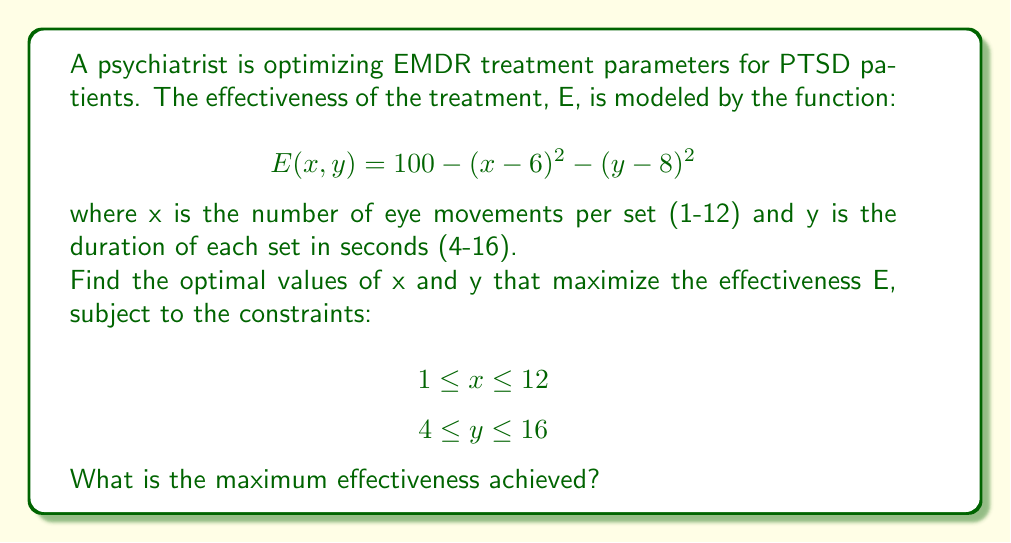Give your solution to this math problem. To solve this nonlinear programming problem, we'll follow these steps:

1) First, we need to find the critical points of the function E(x, y). We do this by taking partial derivatives and setting them to zero:

   $\frac{\partial E}{\partial x} = -2(x - 6) = 0$
   $\frac{\partial E}{\partial y} = -2(y - 8) = 0$

2) Solving these equations:
   $x = 6$
   $y = 8$

3) This critical point (6, 8) is within our constraints, so it's a candidate for the maximum.

4) To confirm it's a maximum, we can check the second derivatives:

   $\frac{\partial^2 E}{\partial x^2} = -2$
   $\frac{\partial^2 E}{\partial y^2} = -2$

   Both are negative, confirming this is a local maximum.

5) We should also check the boundaries of our constraints:

   At x = 1: E(1, 8) = 75
   At x = 12: E(12, 8) = 64
   At y = 4: E(6, 4) = 84
   At y = 16: E(6, 16) = 36

6) The maximum value at the critical point (6, 8) is:

   E(6, 8) = 100 - (6 - 6)^2 - (8 - 8)^2 = 100

7) This is greater than all boundary values, so it's the global maximum within our constraints.

Therefore, the optimal parameters are x = 6 eye movements per set and y = 8 seconds per set, achieving a maximum effectiveness of 100.
Answer: 100 